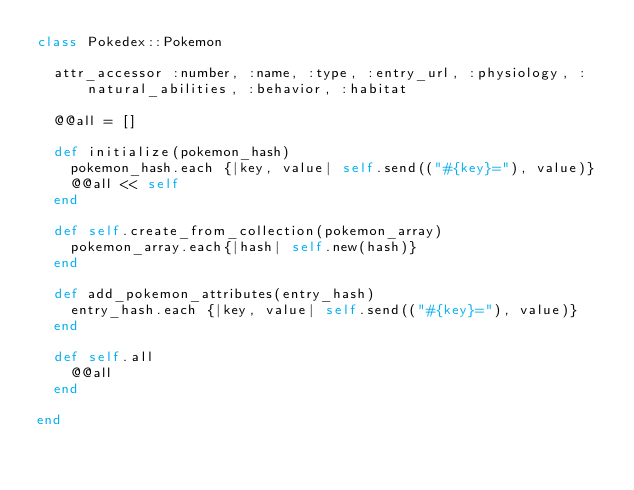Convert code to text. <code><loc_0><loc_0><loc_500><loc_500><_Ruby_>class Pokedex::Pokemon

	attr_accessor :number, :name, :type, :entry_url, :physiology, :natural_abilities, :behavior, :habitat

	@@all = []

	def initialize(pokemon_hash)
		pokemon_hash.each {|key, value| self.send(("#{key}="), value)}
		@@all << self
	end

	def self.create_from_collection(pokemon_array)
		pokemon_array.each{|hash| self.new(hash)}
	end

	def add_pokemon_attributes(entry_hash)
		entry_hash.each {|key, value| self.send(("#{key}="), value)}
	end

	def self.all
		@@all
	end

end</code> 